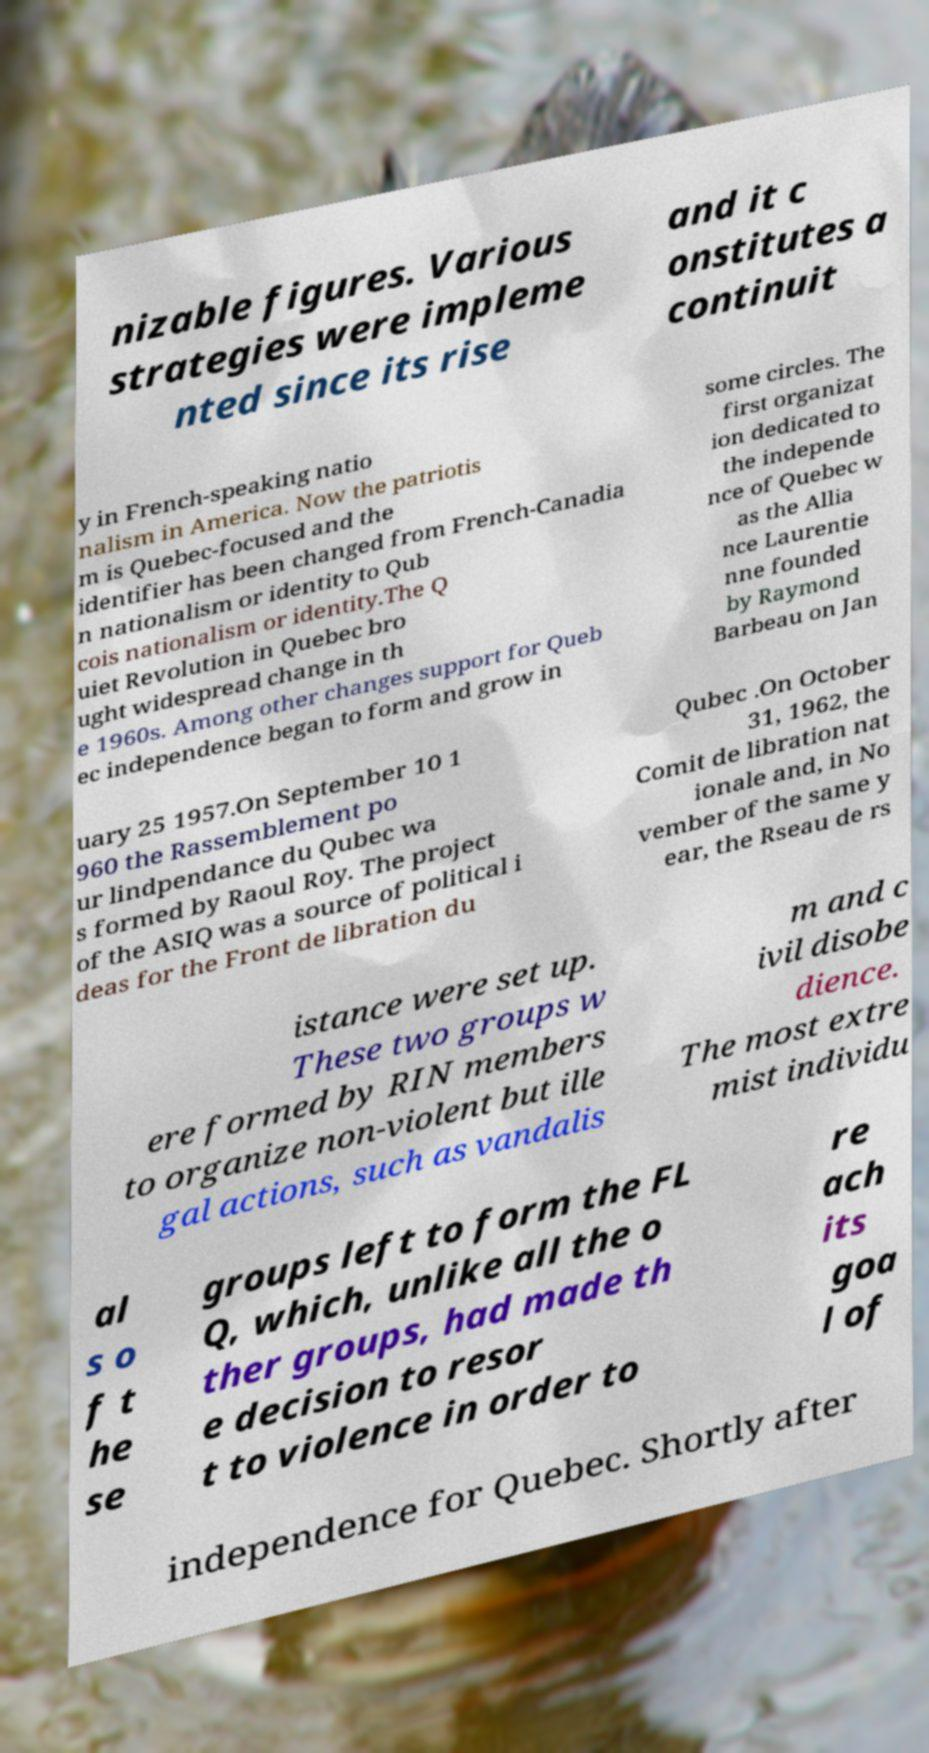For documentation purposes, I need the text within this image transcribed. Could you provide that? nizable figures. Various strategies were impleme nted since its rise and it c onstitutes a continuit y in French-speaking natio nalism in America. Now the patriotis m is Quebec-focused and the identifier has been changed from French-Canadia n nationalism or identity to Qub cois nationalism or identity.The Q uiet Revolution in Quebec bro ught widespread change in th e 1960s. Among other changes support for Queb ec independence began to form and grow in some circles. The first organizat ion dedicated to the independe nce of Quebec w as the Allia nce Laurentie nne founded by Raymond Barbeau on Jan uary 25 1957.On September 10 1 960 the Rassemblement po ur lindpendance du Qubec wa s formed by Raoul Roy. The project of the ASIQ was a source of political i deas for the Front de libration du Qubec .On October 31, 1962, the Comit de libration nat ionale and, in No vember of the same y ear, the Rseau de rs istance were set up. These two groups w ere formed by RIN members to organize non-violent but ille gal actions, such as vandalis m and c ivil disobe dience. The most extre mist individu al s o f t he se groups left to form the FL Q, which, unlike all the o ther groups, had made th e decision to resor t to violence in order to re ach its goa l of independence for Quebec. Shortly after 